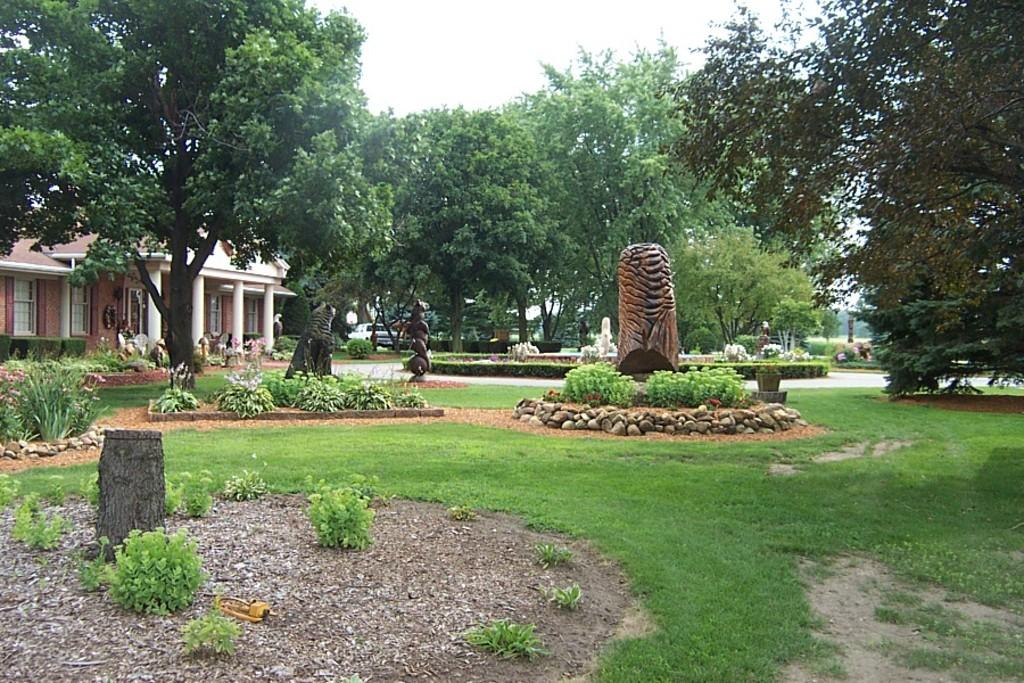What type of artwork can be seen in the image? There are sculptures in the image. What type of natural environment is present in the image? There is grass, plants, rocks, trees, and the sky visible in the image. What type of structure is present in the image? There is a building in the image. Can you tell me the direction the donkey is facing in the image? There is no donkey present in the image. What type of board is being used by the people in the image? There are no people or boards present in the image. 